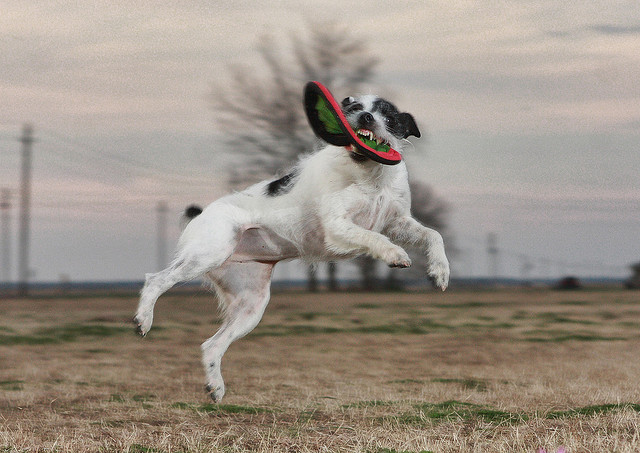How many dogs? 1 